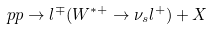Convert formula to latex. <formula><loc_0><loc_0><loc_500><loc_500>p p \rightarrow l ^ { \mp } ( W ^ { * + } \rightarrow \nu _ { s } l ^ { + } ) + X</formula> 